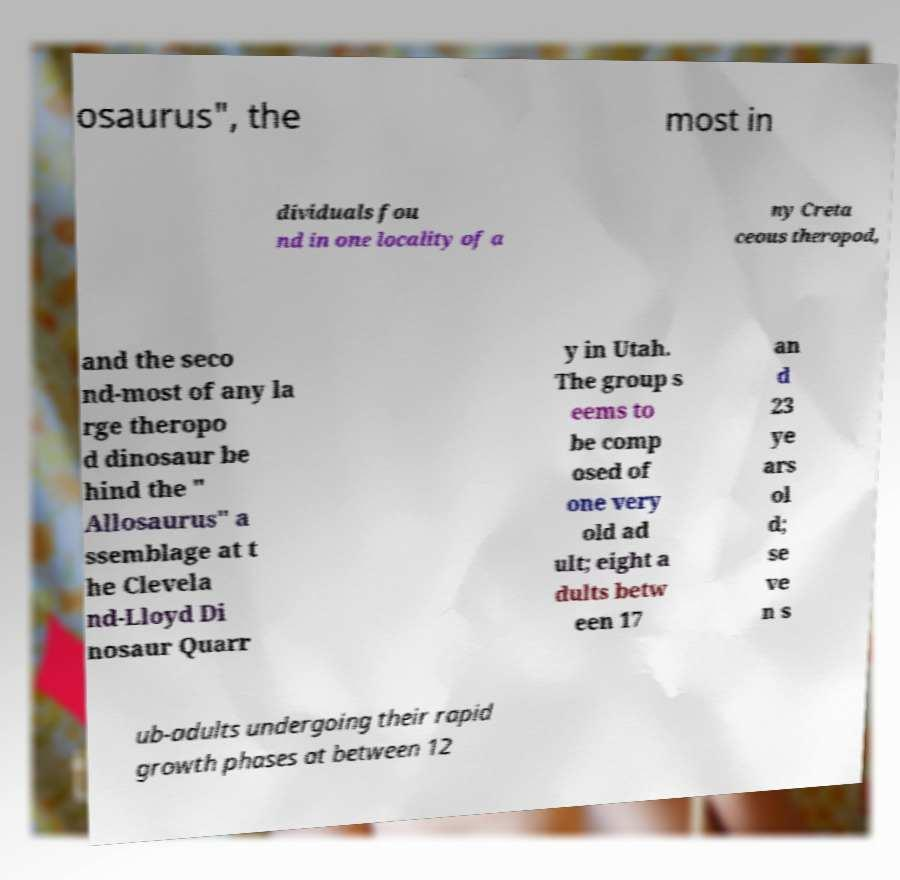Could you assist in decoding the text presented in this image and type it out clearly? osaurus", the most in dividuals fou nd in one locality of a ny Creta ceous theropod, and the seco nd-most of any la rge theropo d dinosaur be hind the " Allosaurus" a ssemblage at t he Clevela nd-Lloyd Di nosaur Quarr y in Utah. The group s eems to be comp osed of one very old ad ult; eight a dults betw een 17 an d 23 ye ars ol d; se ve n s ub-adults undergoing their rapid growth phases at between 12 